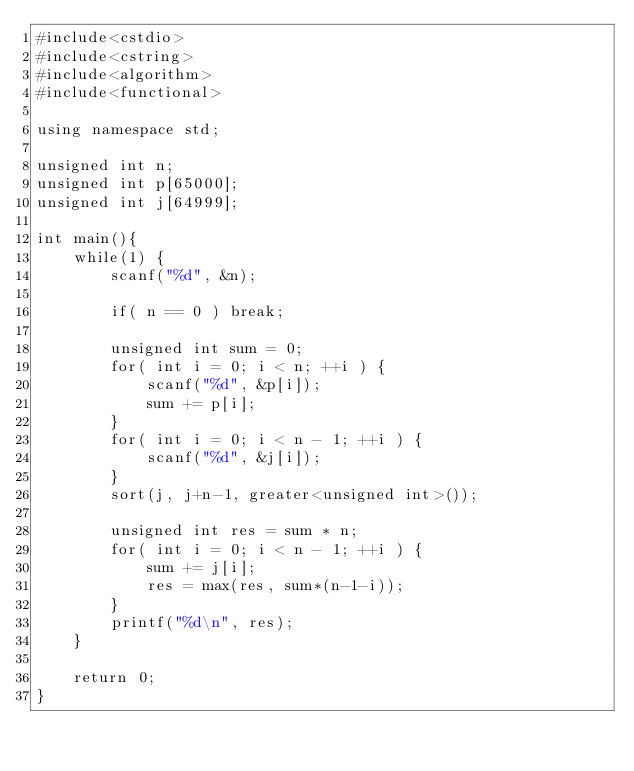<code> <loc_0><loc_0><loc_500><loc_500><_C++_>#include<cstdio>
#include<cstring>
#include<algorithm>
#include<functional>

using namespace std;

unsigned int n;
unsigned int p[65000];
unsigned int j[64999];

int main(){
	while(1) {
		scanf("%d", &n);

		if( n == 0 ) break;

		unsigned int sum = 0;
		for( int i = 0; i < n; ++i ) {
			scanf("%d", &p[i]);
			sum += p[i];
		}
		for( int i = 0; i < n - 1; ++i ) {
			scanf("%d", &j[i]);
		}
		sort(j, j+n-1, greater<unsigned int>());

		unsigned int res = sum * n;
		for( int i = 0; i < n - 1; ++i ) {
			sum += j[i];
			res = max(res, sum*(n-1-i));
		}
		printf("%d\n", res);
	}

	return 0;
}</code> 